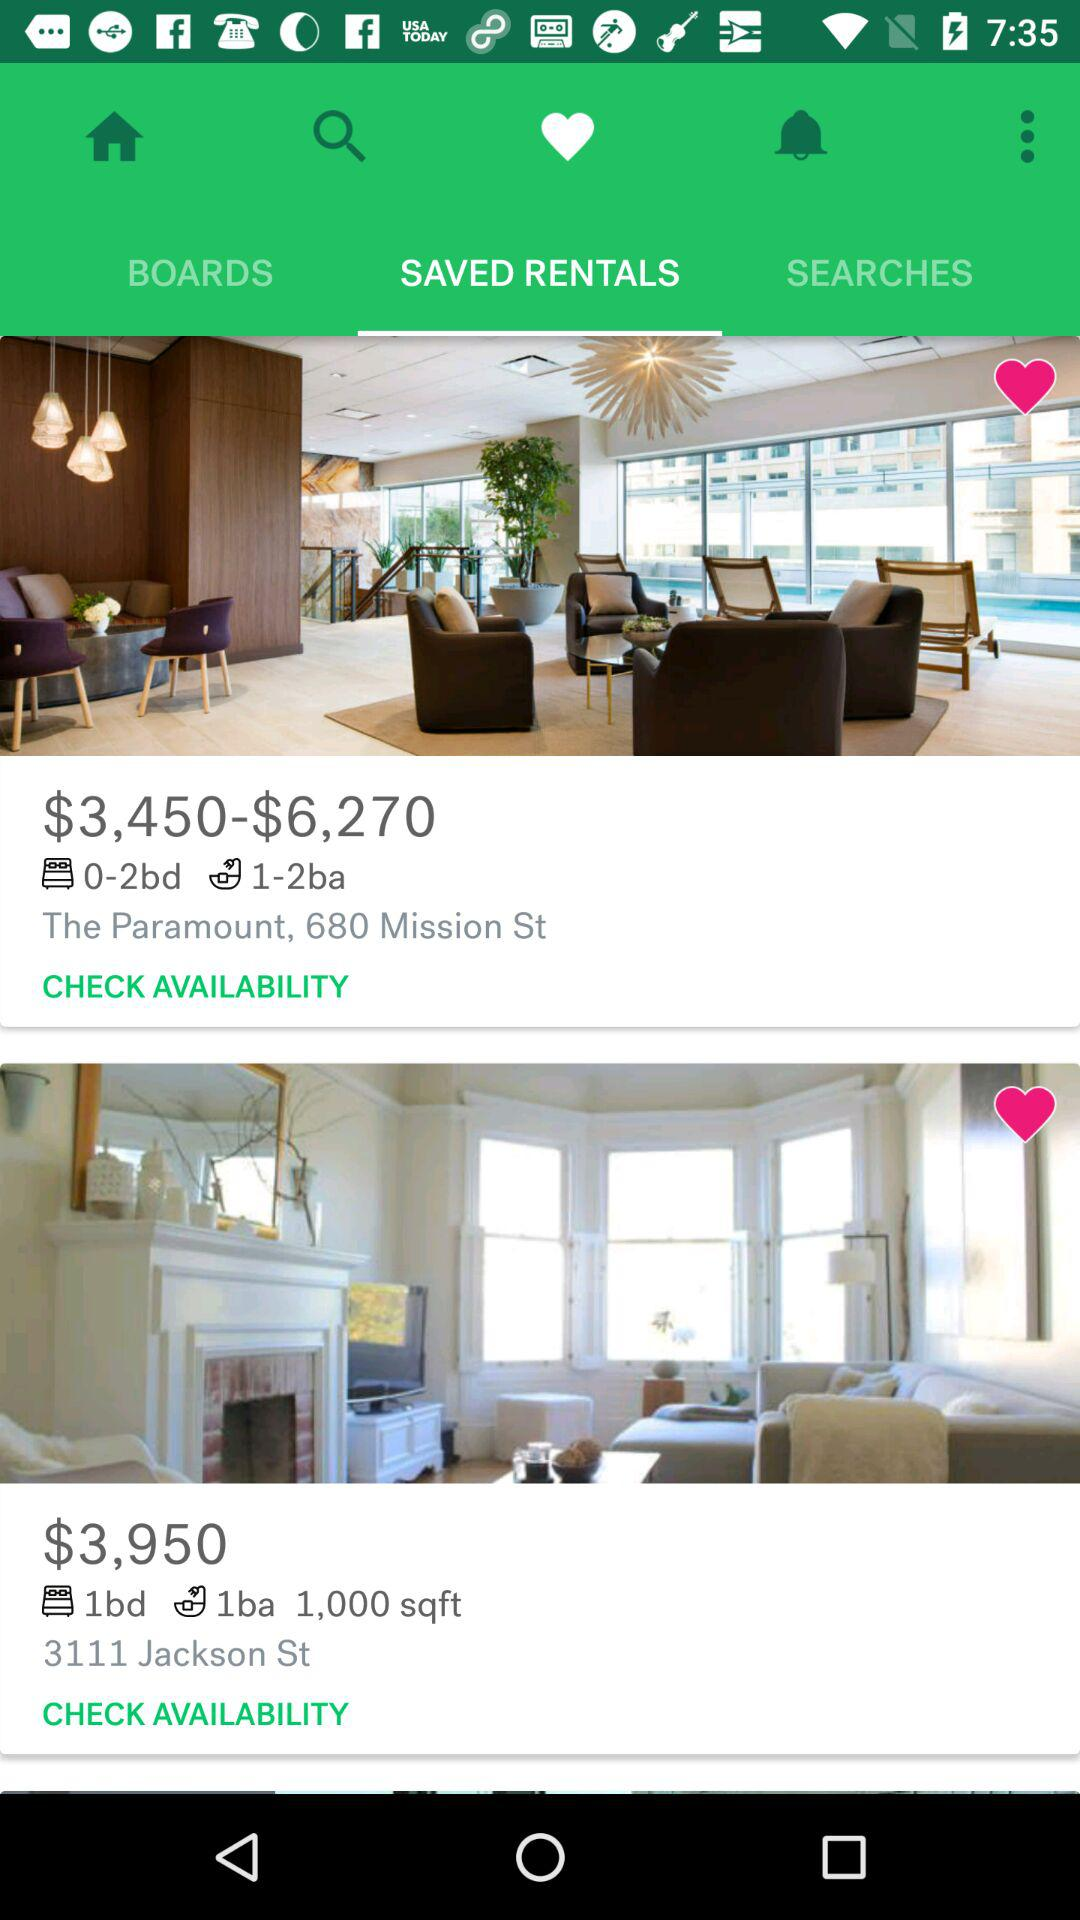How many bedrooms and bathrooms are there in the 1000 square feet rental property? There is 1 bedroom and 1 bathroom in the 1000 square feet rental property. 